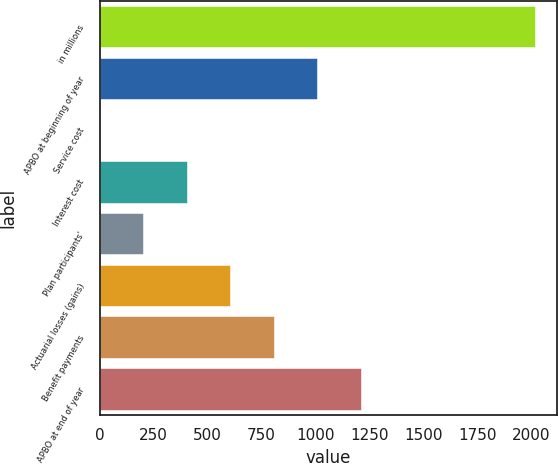Convert chart. <chart><loc_0><loc_0><loc_500><loc_500><bar_chart><fcel>in millions<fcel>APBO at beginning of year<fcel>Service cost<fcel>Interest cost<fcel>Plan participants'<fcel>Actuarial losses (gains)<fcel>Benefit payments<fcel>APBO at end of year<nl><fcel>2017<fcel>1009<fcel>1<fcel>404.2<fcel>202.6<fcel>605.8<fcel>807.4<fcel>1210.6<nl></chart> 